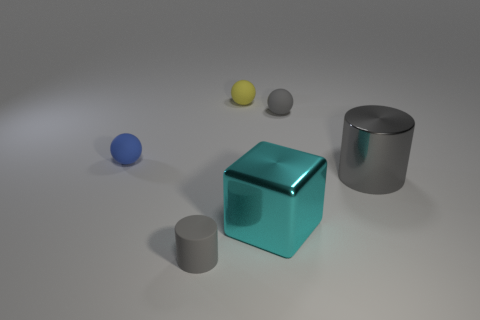What number of tiny gray objects are behind the metallic block and in front of the big cylinder?
Your response must be concise. 0. Is the size of the metal object in front of the big gray cylinder the same as the object behind the gray ball?
Provide a succinct answer. No. How many objects are gray cylinders on the right side of the metallic block or blue matte objects?
Offer a very short reply. 2. What is the material of the small gray object that is behind the tiny blue rubber ball?
Give a very brief answer. Rubber. What is the material of the big cyan cube?
Offer a terse response. Metal. What material is the tiny ball in front of the tiny gray object that is behind the tiny gray matte object that is in front of the blue rubber object made of?
Your answer should be very brief. Rubber. Is there anything else that is made of the same material as the large cube?
Provide a short and direct response. Yes. There is a gray sphere; is its size the same as the cylinder right of the tiny yellow thing?
Ensure brevity in your answer.  No. How many things are either metal objects that are on the right side of the cyan thing or rubber things that are behind the large gray cylinder?
Make the answer very short. 4. What is the color of the cylinder on the right side of the yellow matte thing?
Offer a terse response. Gray. 